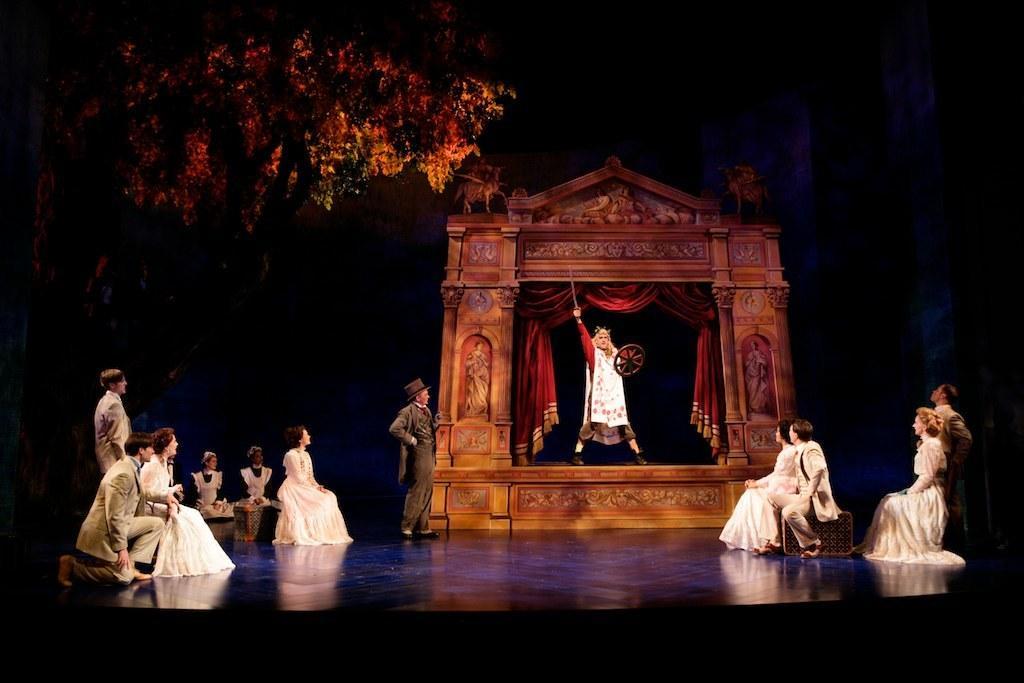In one or two sentences, can you explain what this image depicts? In this image I can see group of people, some are sitting and some are standing. In the background I can see an arch and few trees. 